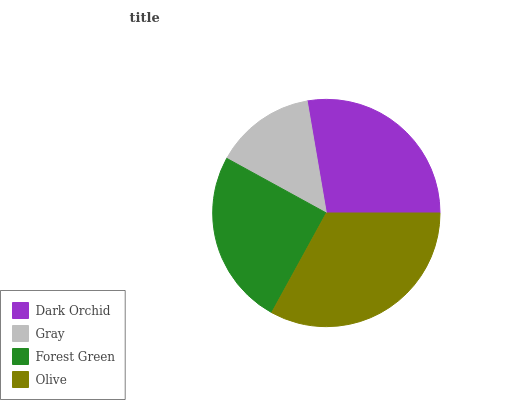Is Gray the minimum?
Answer yes or no. Yes. Is Olive the maximum?
Answer yes or no. Yes. Is Forest Green the minimum?
Answer yes or no. No. Is Forest Green the maximum?
Answer yes or no. No. Is Forest Green greater than Gray?
Answer yes or no. Yes. Is Gray less than Forest Green?
Answer yes or no. Yes. Is Gray greater than Forest Green?
Answer yes or no. No. Is Forest Green less than Gray?
Answer yes or no. No. Is Dark Orchid the high median?
Answer yes or no. Yes. Is Forest Green the low median?
Answer yes or no. Yes. Is Olive the high median?
Answer yes or no. No. Is Olive the low median?
Answer yes or no. No. 